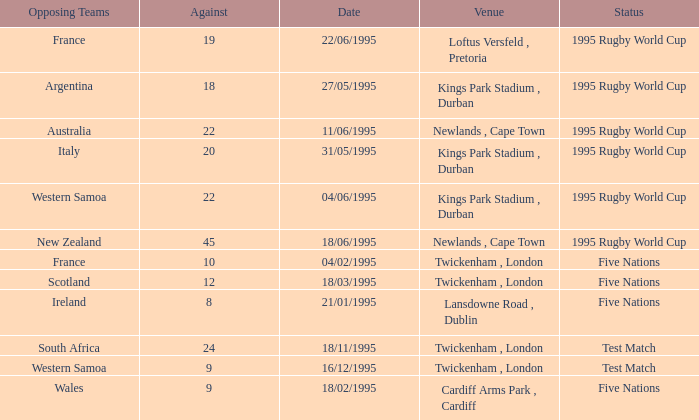What's the total against for opposing team scotland at twickenham, london venue with a status of five nations? 1.0. 